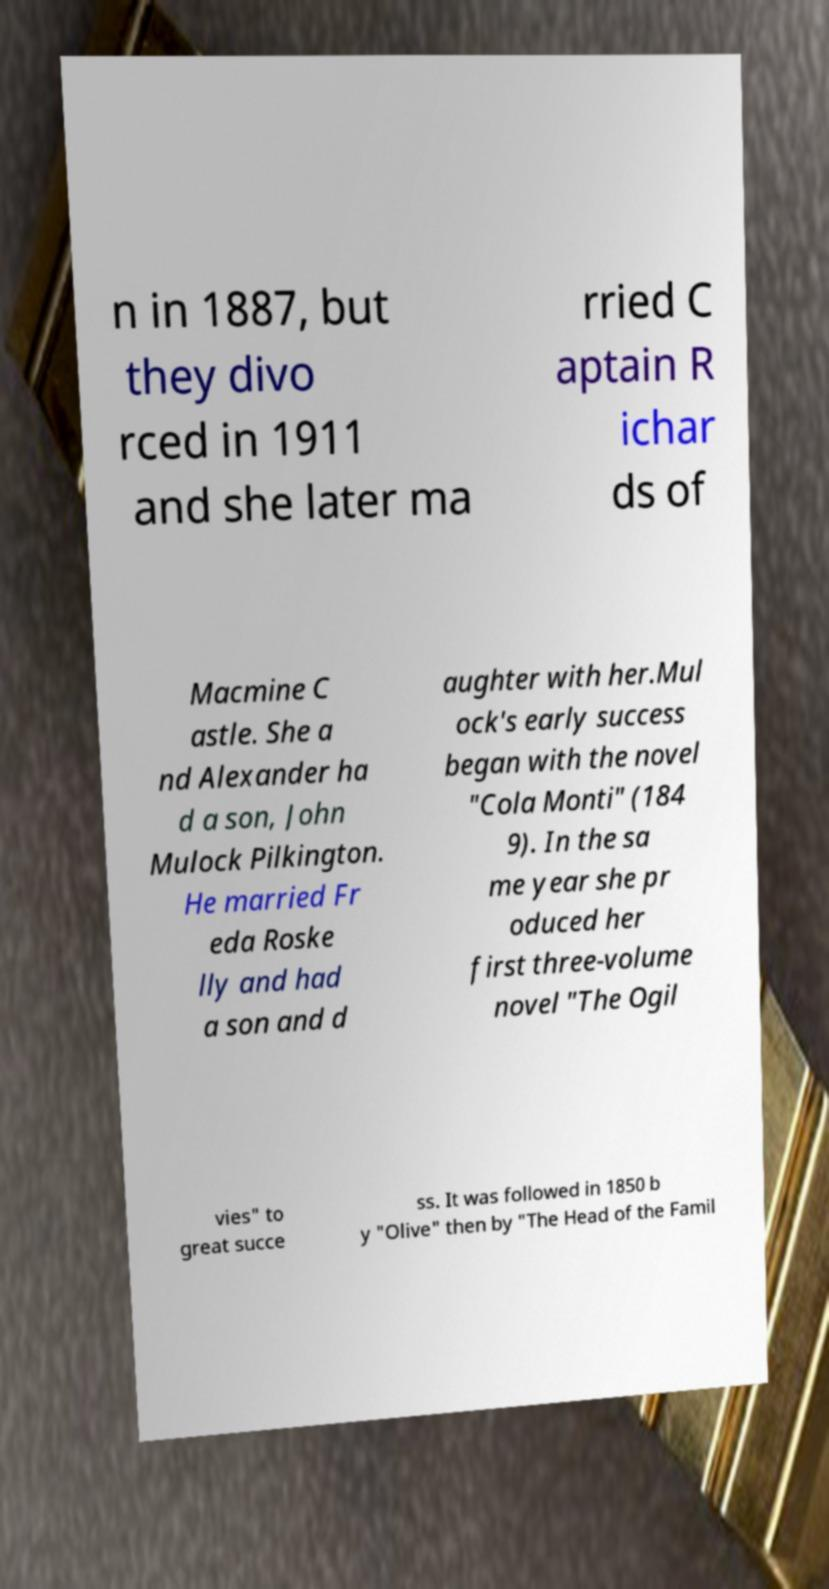Could you extract and type out the text from this image? n in 1887, but they divo rced in 1911 and she later ma rried C aptain R ichar ds of Macmine C astle. She a nd Alexander ha d a son, John Mulock Pilkington. He married Fr eda Roske lly and had a son and d aughter with her.Mul ock's early success began with the novel "Cola Monti" (184 9). In the sa me year she pr oduced her first three-volume novel "The Ogil vies" to great succe ss. It was followed in 1850 b y "Olive" then by "The Head of the Famil 